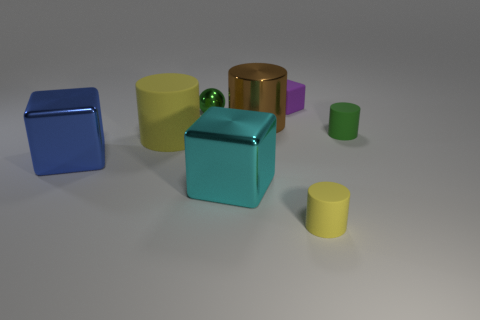Add 1 purple cubes. How many objects exist? 9 Subtract all cubes. How many objects are left? 5 Add 3 cyan cubes. How many cyan cubes are left? 4 Add 6 tiny purple matte objects. How many tiny purple matte objects exist? 7 Subtract 0 blue cylinders. How many objects are left? 8 Subtract all small green matte cylinders. Subtract all large blocks. How many objects are left? 5 